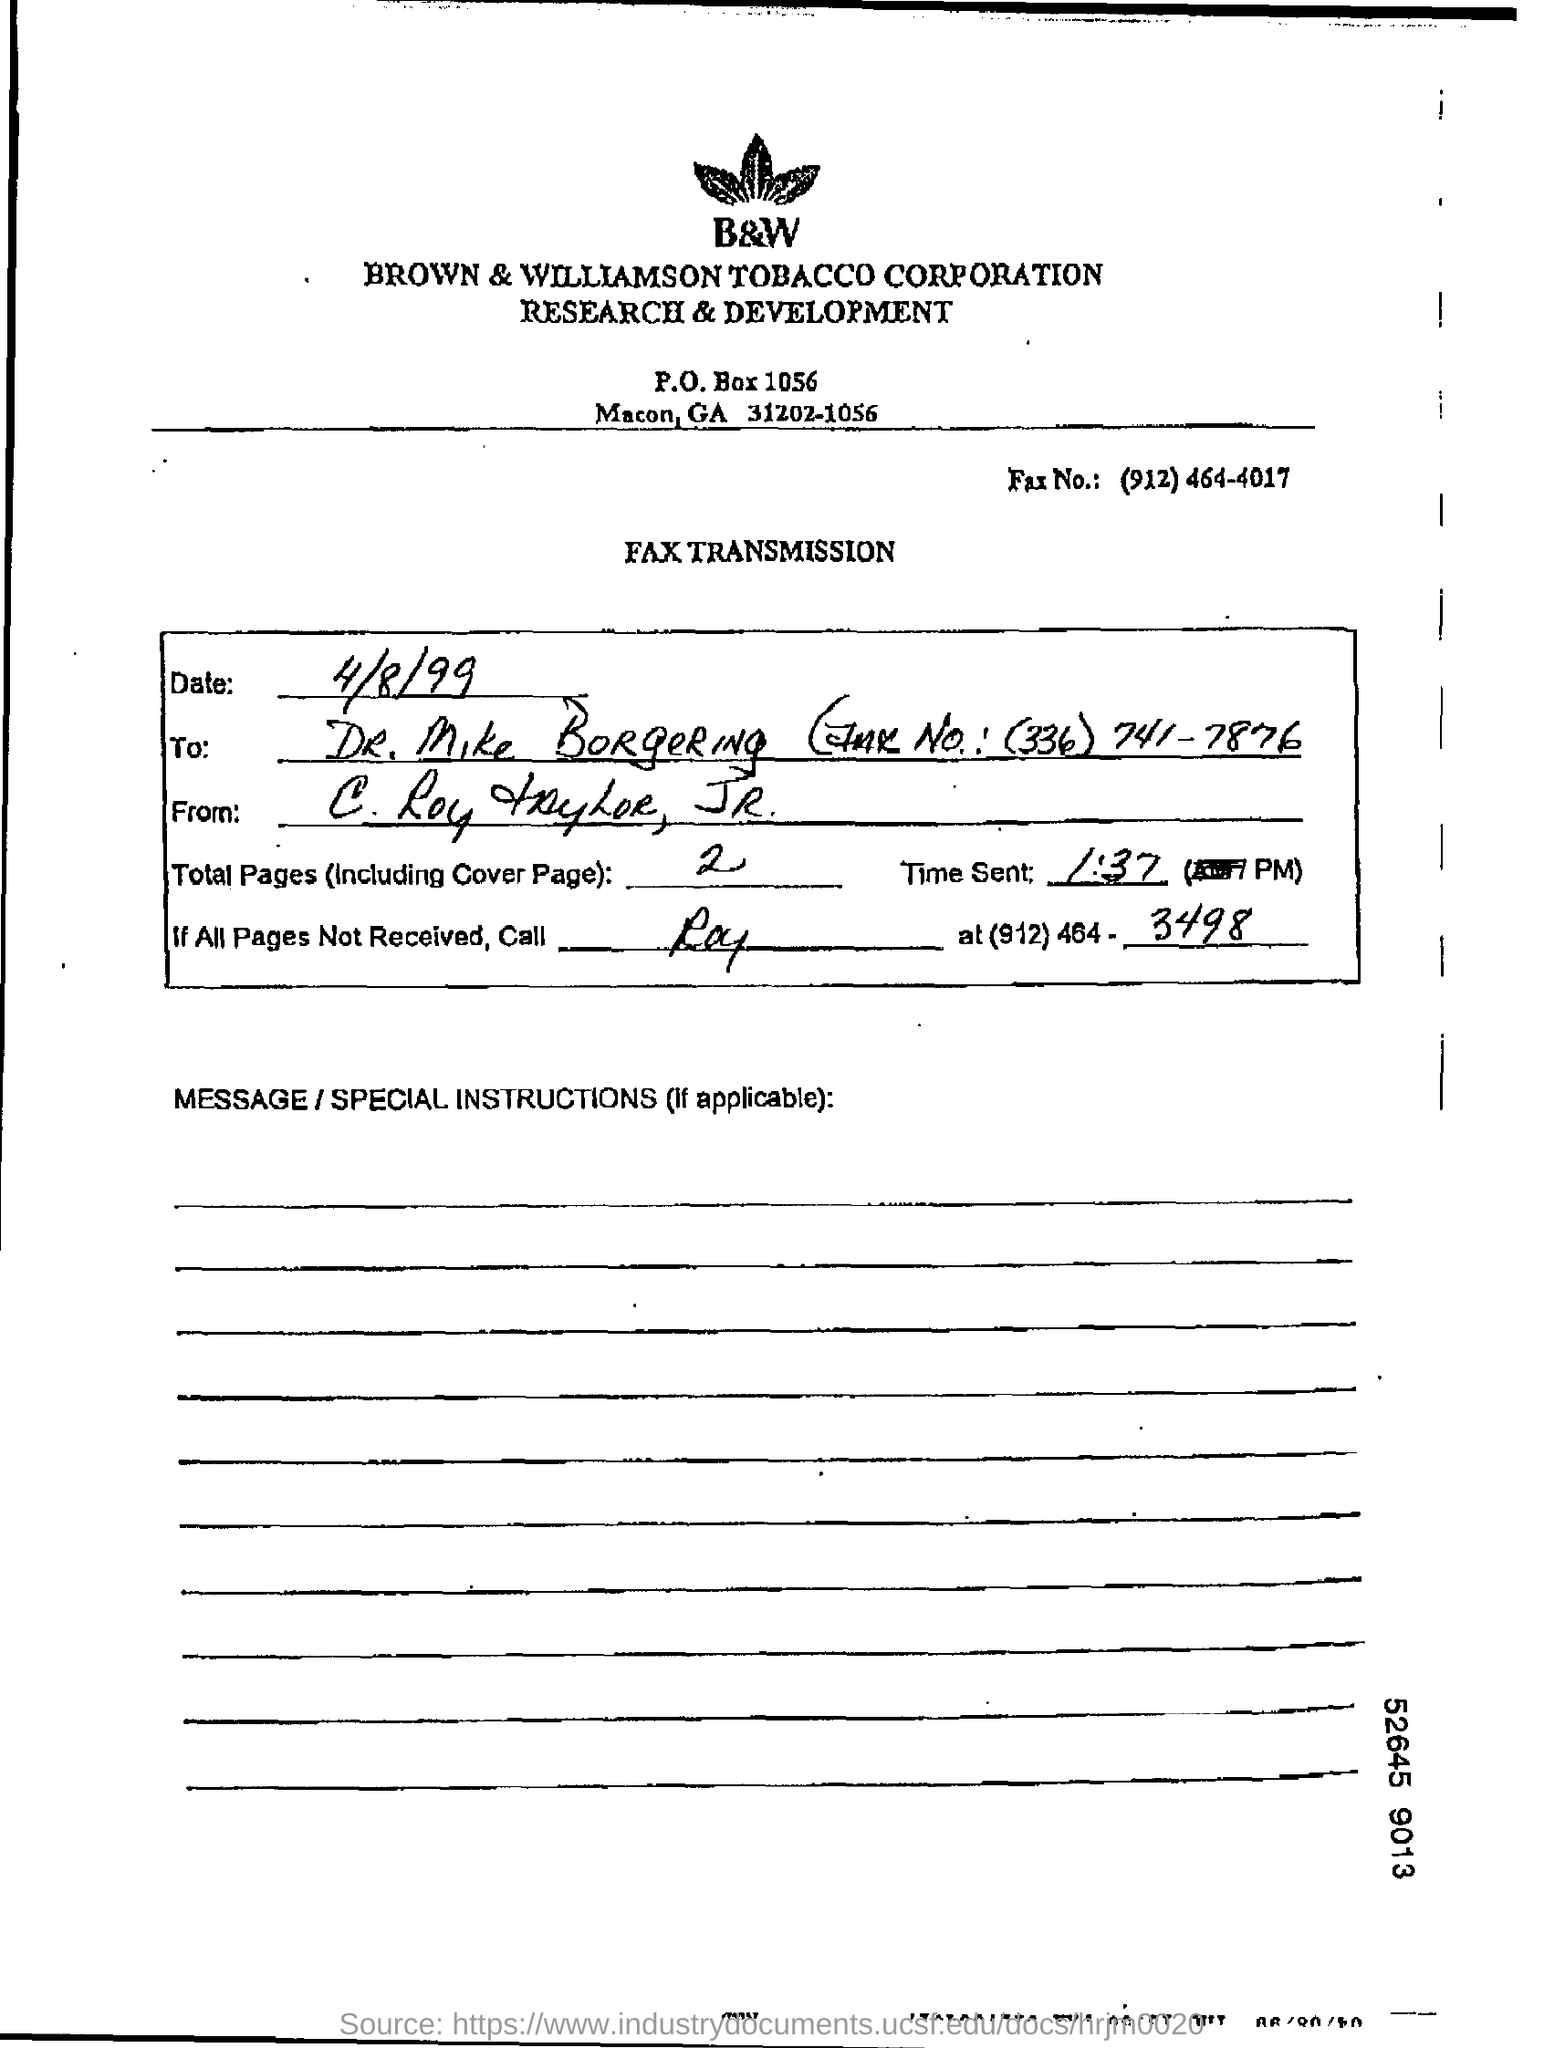What is the p.o. box number ?
Ensure brevity in your answer.  1056. What kind of transmission it is?
Offer a very short reply. FAX TRANSMISSION. What is the number of fax ?
Offer a terse response. (912)464-4017. 